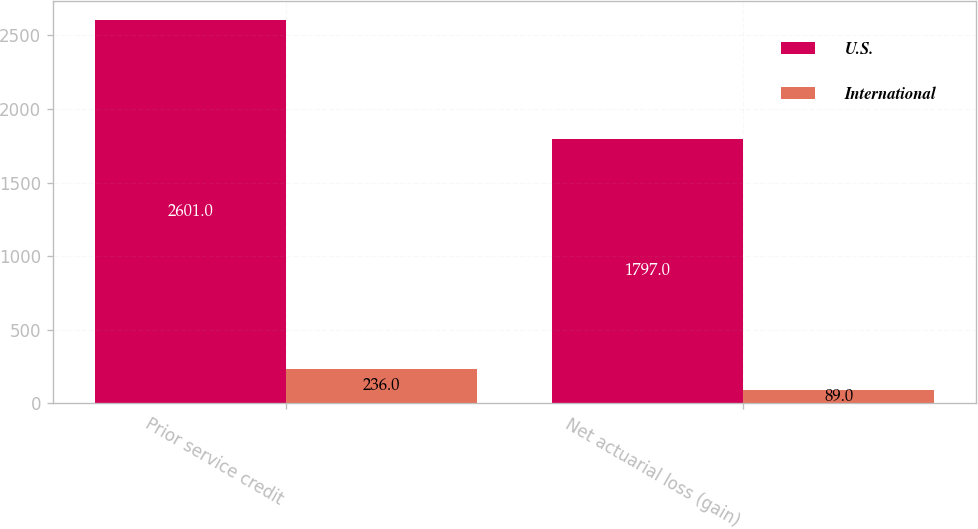Convert chart. <chart><loc_0><loc_0><loc_500><loc_500><stacked_bar_chart><ecel><fcel>Prior service credit<fcel>Net actuarial loss (gain)<nl><fcel>U.S.<fcel>2601<fcel>1797<nl><fcel>International<fcel>236<fcel>89<nl></chart> 